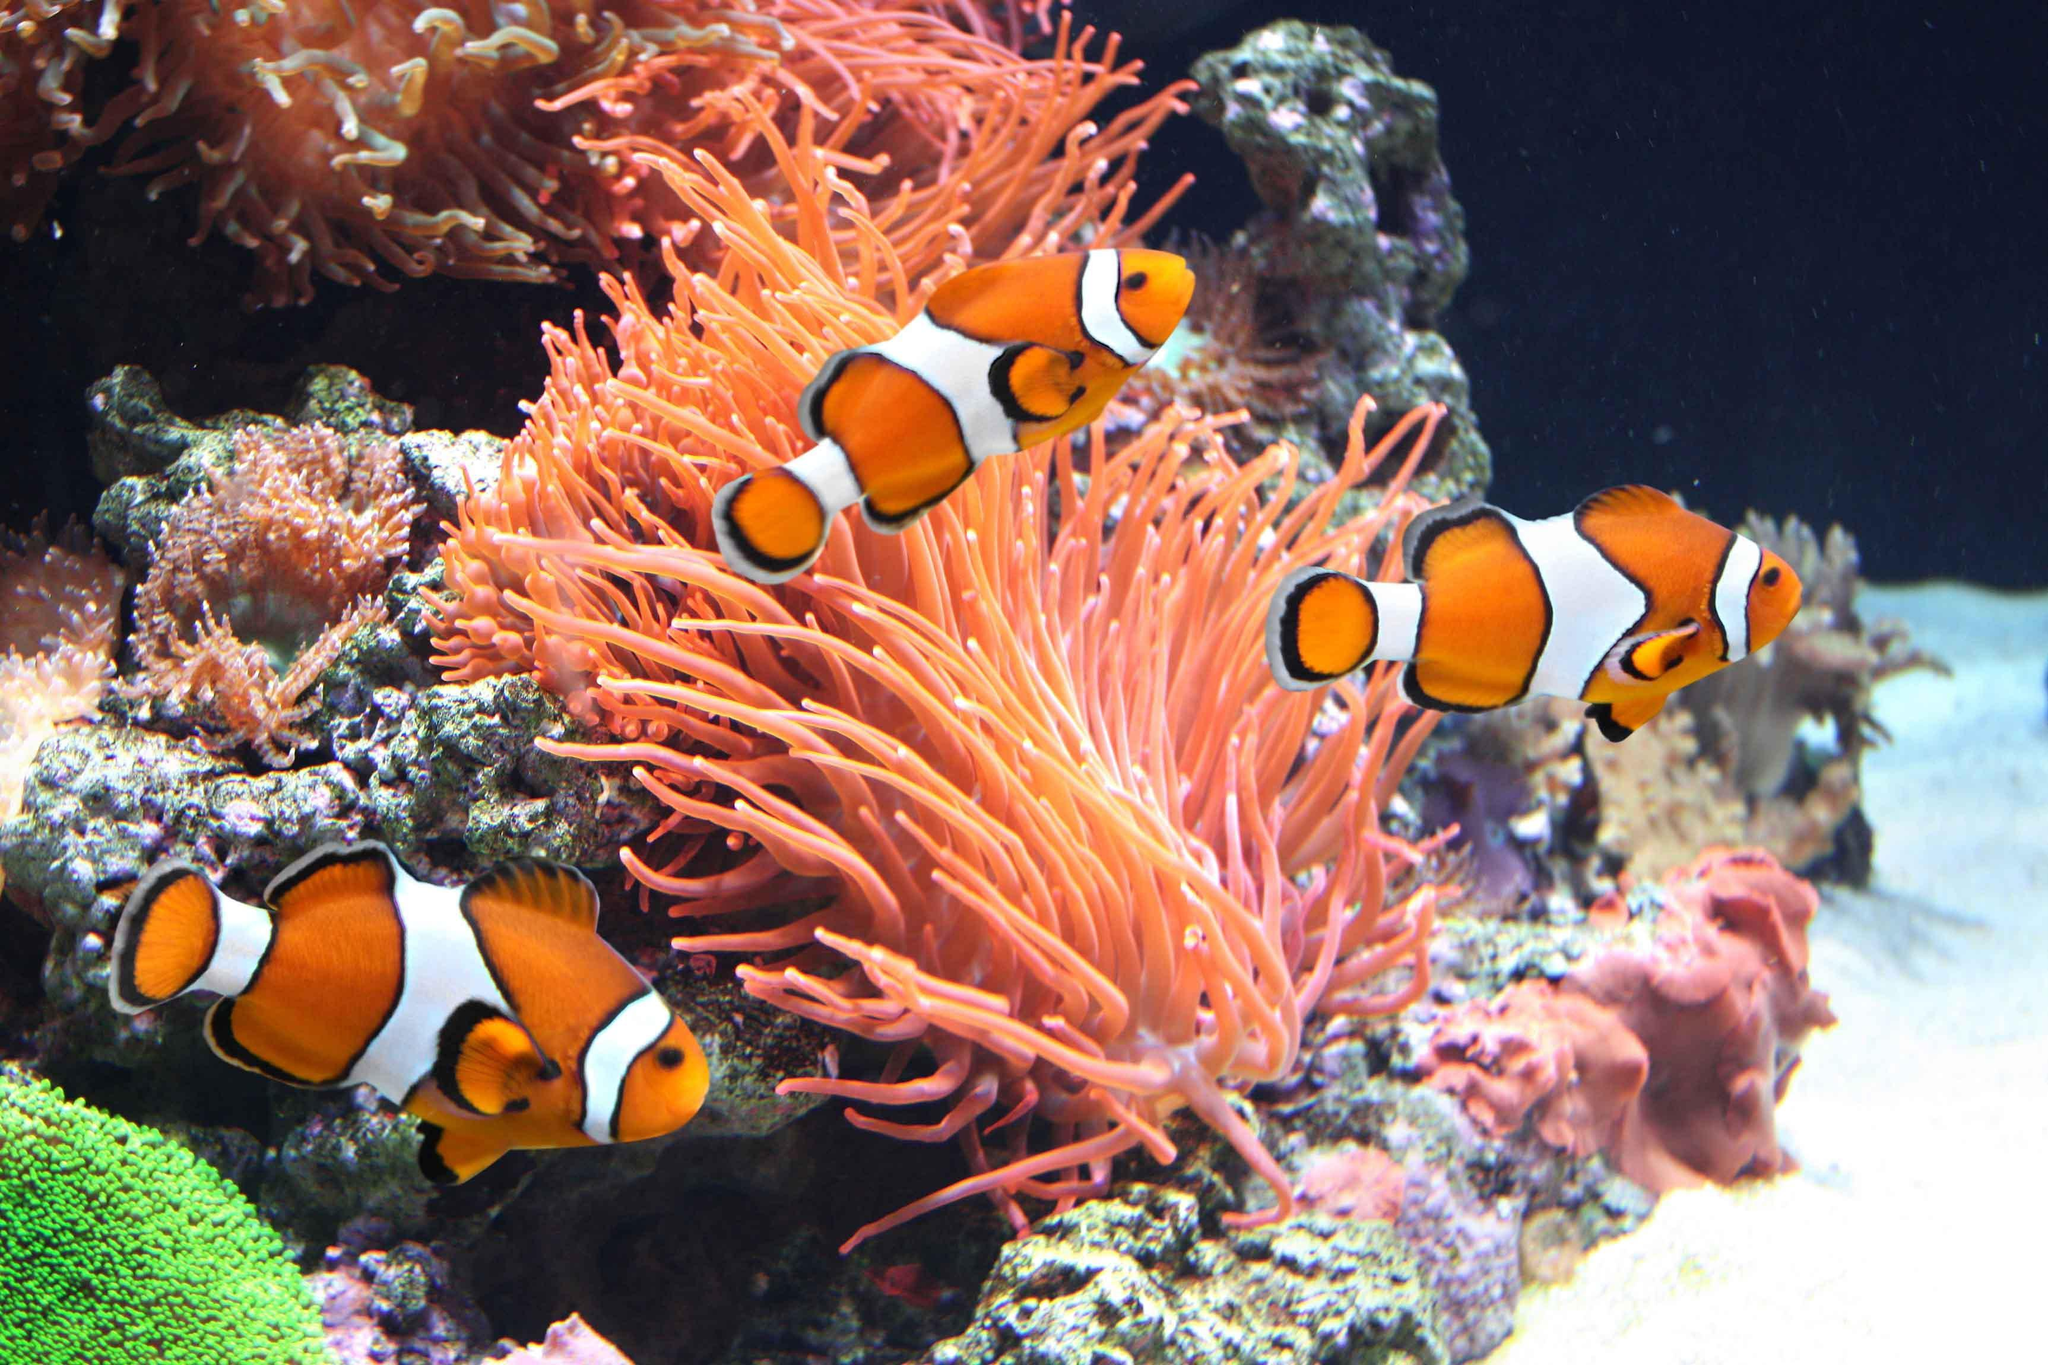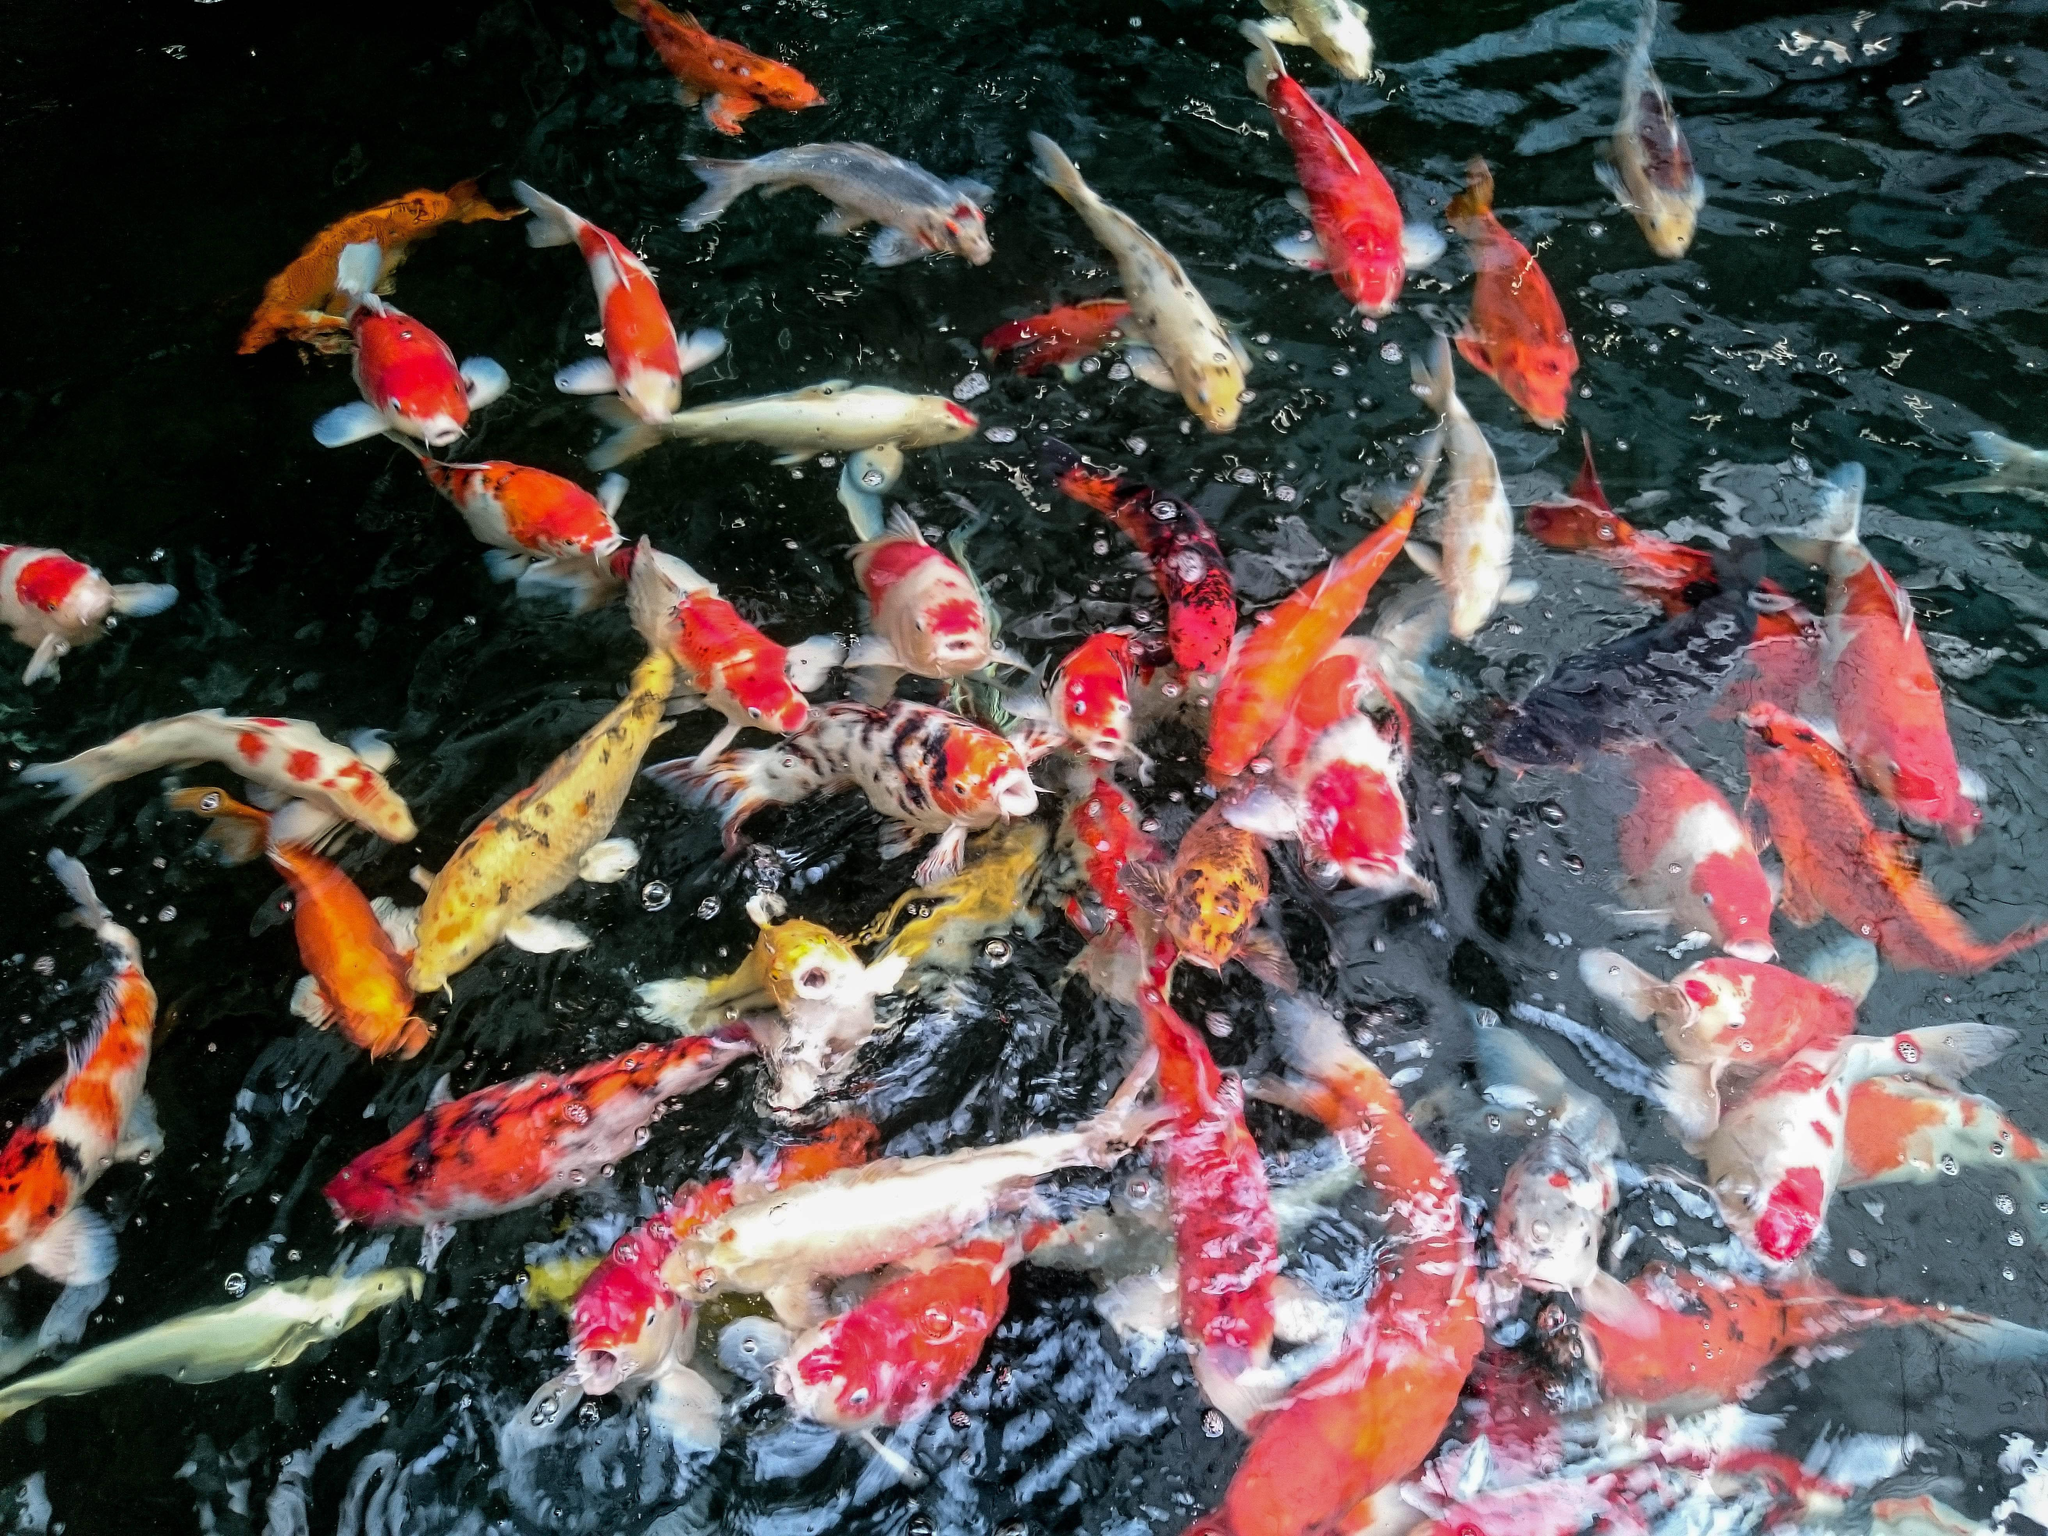The first image is the image on the left, the second image is the image on the right. For the images shown, is this caption "The right image shows a single prominent fish displayed in profile with some blue coloring, and the left image shows beds of coral or anemone with no fish present and with touches of violet color." true? Answer yes or no. No. The first image is the image on the left, the second image is the image on the right. For the images shown, is this caption "Some fish are facing toward the right." true? Answer yes or no. Yes. 